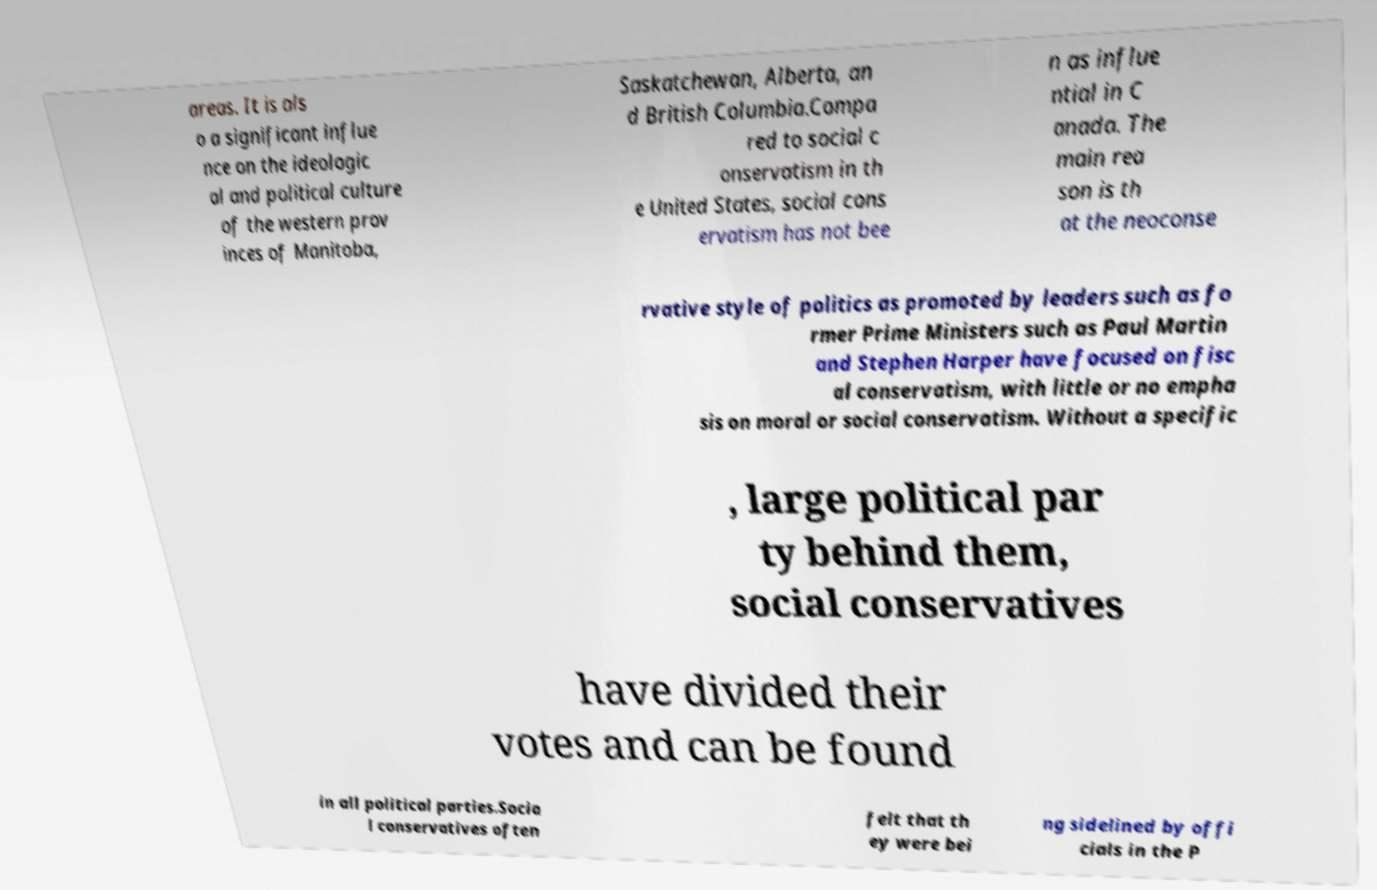Please identify and transcribe the text found in this image. areas. It is als o a significant influe nce on the ideologic al and political culture of the western prov inces of Manitoba, Saskatchewan, Alberta, an d British Columbia.Compa red to social c onservatism in th e United States, social cons ervatism has not bee n as influe ntial in C anada. The main rea son is th at the neoconse rvative style of politics as promoted by leaders such as fo rmer Prime Ministers such as Paul Martin and Stephen Harper have focused on fisc al conservatism, with little or no empha sis on moral or social conservatism. Without a specific , large political par ty behind them, social conservatives have divided their votes and can be found in all political parties.Socia l conservatives often felt that th ey were bei ng sidelined by offi cials in the P 